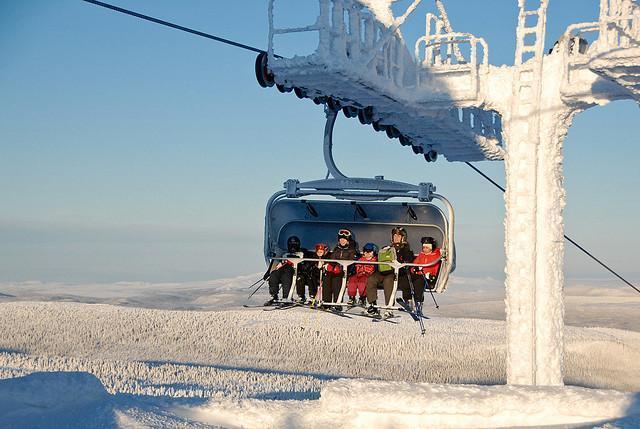Where is this group headed?
Select the accurate answer and provide explanation: 'Answer: answer
Rationale: rationale.'
Options: Disney world, down, no where, up. Answer: up.
Rationale: The group goes up. 